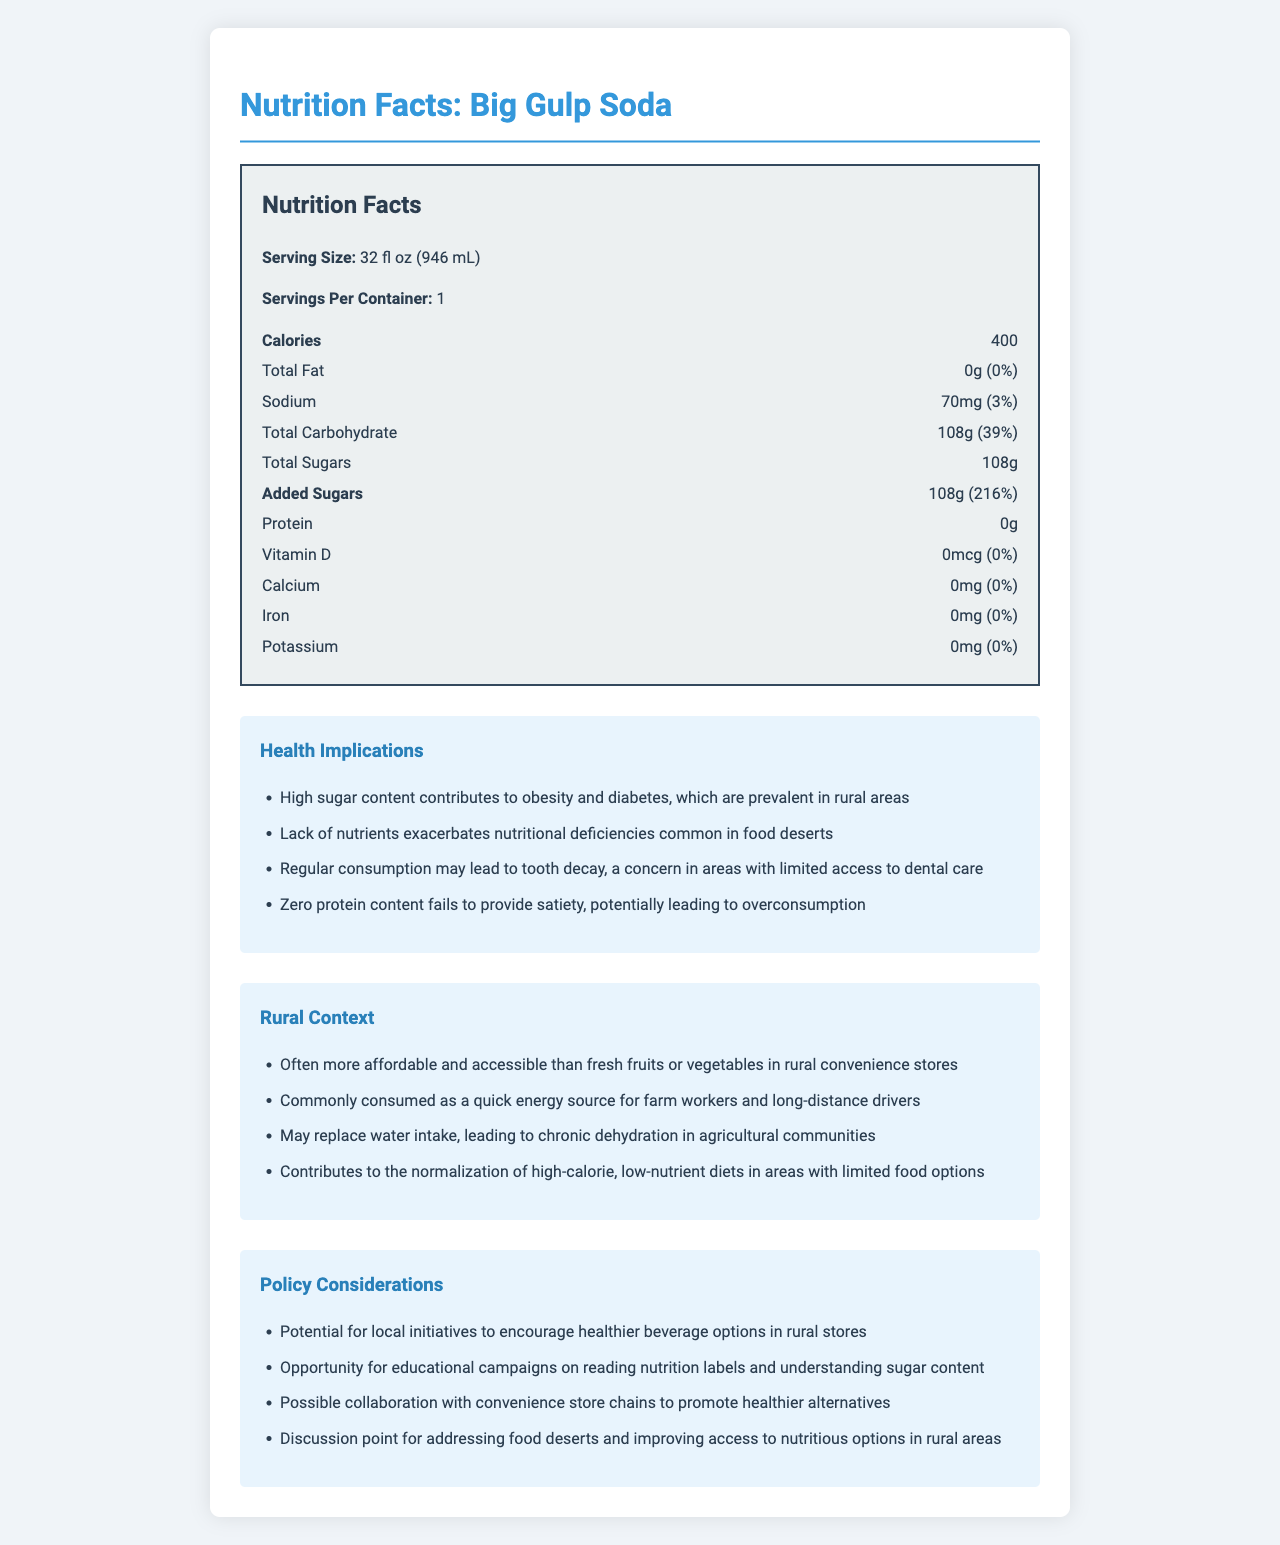What is the serving size for Big Gulp Soda? The serving size is clearly mentioned as "32 fl oz (946 mL)" on the document.
Answer: 32 fl oz (946 mL) How many grams of total sugars are in one serving of Big Gulp Soda? The document specifies that the total sugars per serving are 108g, including added sugars.
Answer: 108g What percentage of the daily value for added sugars does a serving of Big Gulp Soda represent? The document states that the added sugars amount is 108g, which represents 216% of the daily value.
Answer: 216% Does Big Gulp Soda contain any protein? The document lists the protein content as 0g, indicating there is no protein in the product.
Answer: No How much sodium does Big Gulp Soda contain per serving? The nutrition label shows that there are 70mg of sodium per serving.
Answer: 70mg Which of the following nutrients is absent in Big Gulp Soda? A. Calcium B. Iron C. Vitamin D D. All of the above The document states that the amounts for calcium, iron, and vitamin D are all 0mg, meaning none is present in the soda.
Answer: D. All of the above What is the calorie content per serving of Big Gulp Soda? The nutrition label indicates that there are 400 calories per 32 fl oz serving.
Answer: 400 calories Considering overall nutritional value, should Big Gulp Soda be consumed regularly as part of a healthy diet? The high sugar content and lack of essential nutrients make it unsuitable for regular consumption as part of a healthy diet.
Answer: No What is one potential health implication of consuming Big Gulp Soda in rural areas? (Choose one) A. Increased energy levels B. Prevention of nutritional deficiencies C. Contribution to obesity and diabetes The document lists that the high sugar content of Big Gulp Soda contributes to obesity and diabetes, particularly in rural areas with limited access to fresh foods.
Answer: C. Contribution to obesity and diabetes What is a notable policy consideration mentioned for Big Gulp Soda? A. Promote its consumption for energy B. Ban its sale in rural areas C. Encourage healthier beverage options in rural stores One of the policy considerations mentioned in the document is the potential for local initiatives to encourage healthier beverage options in rural stores.
Answer: C. Encourage healthier beverage options in rural stores Is it true that Big Gulp Soda contains significant amounts of essential vitamins and minerals? The document shows that Big Gulp Soda contains 0% daily values for vitamin D, calcium, iron, and potassium, meaning it does not provide significant amounts of these essential nutrients.
Answer: False Summarize the main idea of the document. The document provides detailed nutrition information about Big Gulp Soda, highlights health implications and specific challenges faced by rural areas, and suggests policy considerations to promote healthier dietary options.
Answer: Big Gulp Soda is a high-sugar, calorie-dense beverage with no significant nutritional value, posing health risks like obesity and diabetes, especially in rural areas with limited access to fresh and healthy foods. The document discusses potential policy considerations to address these issues. How often do rural convenience store patrons replace water with Big Gulp Soda? The document does not provide specific frequency data on how often rural convenience store patrons replace water with Big Gulp Soda.
Answer: Cannot be determined 